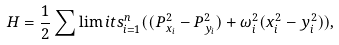Convert formula to latex. <formula><loc_0><loc_0><loc_500><loc_500>H = \frac { 1 } { 2 } \sum \lim i t s _ { i = 1 } ^ { n } ( ( P _ { x _ { i } } ^ { 2 } - P _ { y _ { i } } ^ { 2 } ) + \omega _ { i } ^ { 2 } ( x _ { i } ^ { 2 } - y _ { i } ^ { 2 } ) ) ,</formula> 